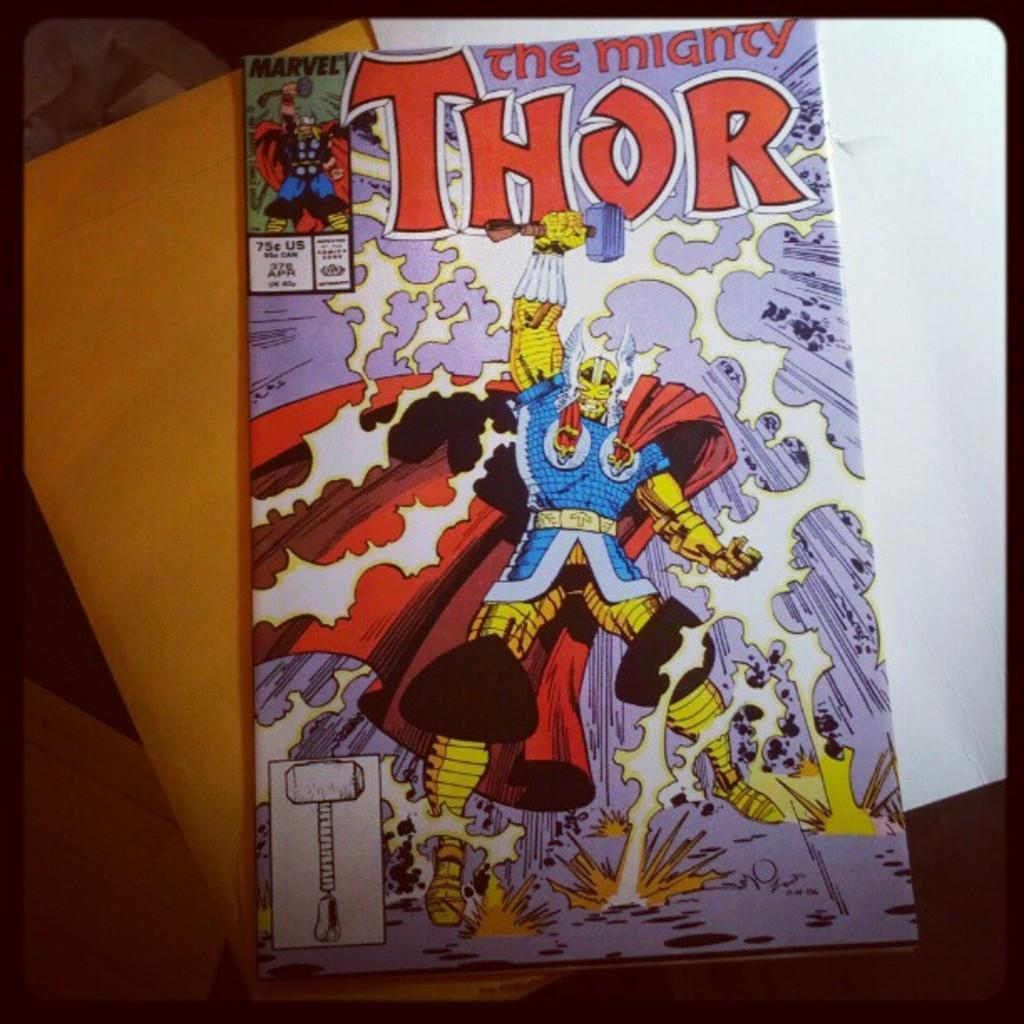What is the main subject of the image? The main subject of the image is the cover page of a book. What can be found on the cover page? The cover page has some text. What colors are present in the background of the image? In the background, there is white and orange color paper. What type of yarn is being sold in the store depicted in the image? There is no store or yarn present in the image; it features a cover page of a book with text and a background of white and orange color paper. 